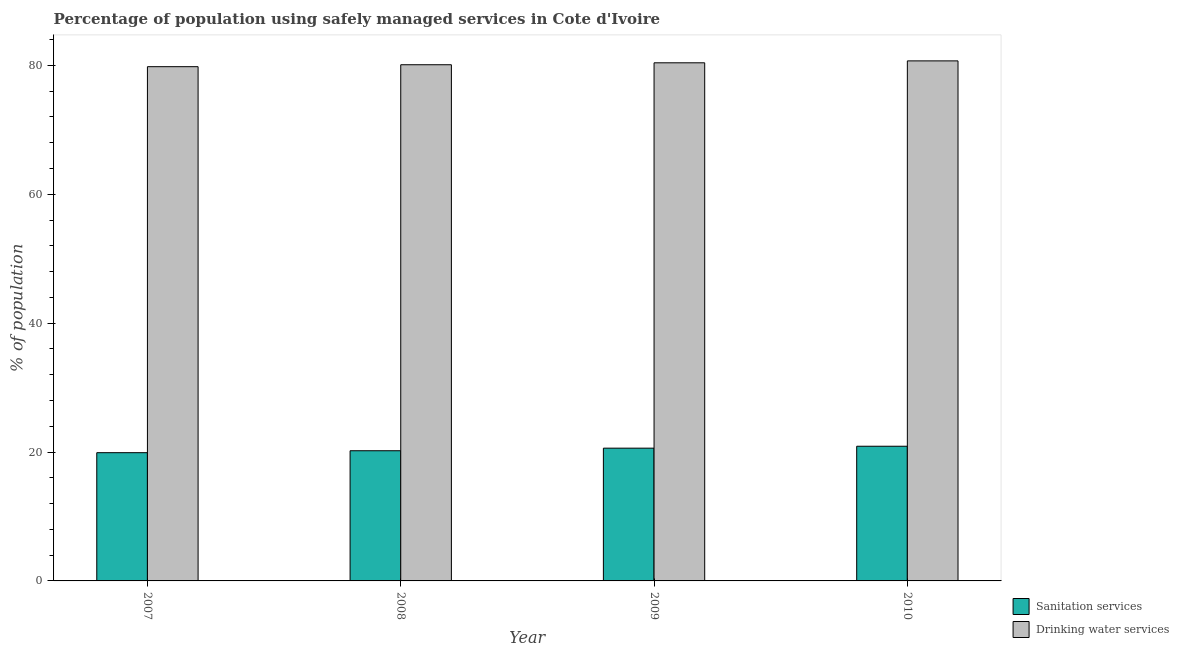How many groups of bars are there?
Offer a terse response. 4. Are the number of bars on each tick of the X-axis equal?
Provide a short and direct response. Yes. How many bars are there on the 3rd tick from the right?
Provide a succinct answer. 2. What is the label of the 4th group of bars from the left?
Keep it short and to the point. 2010. What is the percentage of population who used drinking water services in 2008?
Provide a short and direct response. 80.1. Across all years, what is the maximum percentage of population who used sanitation services?
Offer a terse response. 20.9. In which year was the percentage of population who used sanitation services maximum?
Offer a terse response. 2010. In which year was the percentage of population who used drinking water services minimum?
Provide a short and direct response. 2007. What is the total percentage of population who used drinking water services in the graph?
Make the answer very short. 321. What is the difference between the percentage of population who used drinking water services in 2007 and that in 2009?
Give a very brief answer. -0.6. What is the difference between the percentage of population who used drinking water services in 2008 and the percentage of population who used sanitation services in 2009?
Your response must be concise. -0.3. What is the average percentage of population who used sanitation services per year?
Offer a very short reply. 20.4. In how many years, is the percentage of population who used sanitation services greater than 68 %?
Ensure brevity in your answer.  0. What is the ratio of the percentage of population who used sanitation services in 2008 to that in 2009?
Make the answer very short. 0.98. Is the percentage of population who used drinking water services in 2007 less than that in 2010?
Offer a terse response. Yes. What is the difference between the highest and the second highest percentage of population who used drinking water services?
Your response must be concise. 0.3. What is the difference between the highest and the lowest percentage of population who used drinking water services?
Offer a terse response. 0.9. What does the 2nd bar from the left in 2010 represents?
Keep it short and to the point. Drinking water services. What does the 1st bar from the right in 2008 represents?
Your answer should be compact. Drinking water services. How many bars are there?
Provide a short and direct response. 8. How many years are there in the graph?
Keep it short and to the point. 4. Does the graph contain grids?
Keep it short and to the point. No. How many legend labels are there?
Your response must be concise. 2. How are the legend labels stacked?
Your answer should be very brief. Vertical. What is the title of the graph?
Give a very brief answer. Percentage of population using safely managed services in Cote d'Ivoire. What is the label or title of the Y-axis?
Keep it short and to the point. % of population. What is the % of population of Drinking water services in 2007?
Your response must be concise. 79.8. What is the % of population in Sanitation services in 2008?
Your answer should be very brief. 20.2. What is the % of population of Drinking water services in 2008?
Ensure brevity in your answer.  80.1. What is the % of population in Sanitation services in 2009?
Your answer should be very brief. 20.6. What is the % of population in Drinking water services in 2009?
Offer a terse response. 80.4. What is the % of population of Sanitation services in 2010?
Offer a terse response. 20.9. What is the % of population in Drinking water services in 2010?
Provide a succinct answer. 80.7. Across all years, what is the maximum % of population in Sanitation services?
Offer a terse response. 20.9. Across all years, what is the maximum % of population of Drinking water services?
Provide a short and direct response. 80.7. Across all years, what is the minimum % of population of Sanitation services?
Your response must be concise. 19.9. Across all years, what is the minimum % of population of Drinking water services?
Offer a terse response. 79.8. What is the total % of population in Sanitation services in the graph?
Ensure brevity in your answer.  81.6. What is the total % of population in Drinking water services in the graph?
Ensure brevity in your answer.  321. What is the difference between the % of population in Sanitation services in 2007 and that in 2008?
Keep it short and to the point. -0.3. What is the difference between the % of population in Sanitation services in 2007 and that in 2010?
Your response must be concise. -1. What is the difference between the % of population in Drinking water services in 2007 and that in 2010?
Ensure brevity in your answer.  -0.9. What is the difference between the % of population of Drinking water services in 2008 and that in 2009?
Your response must be concise. -0.3. What is the difference between the % of population in Sanitation services in 2008 and that in 2010?
Provide a succinct answer. -0.7. What is the difference between the % of population of Drinking water services in 2009 and that in 2010?
Offer a very short reply. -0.3. What is the difference between the % of population in Sanitation services in 2007 and the % of population in Drinking water services in 2008?
Your answer should be very brief. -60.2. What is the difference between the % of population of Sanitation services in 2007 and the % of population of Drinking water services in 2009?
Offer a very short reply. -60.5. What is the difference between the % of population in Sanitation services in 2007 and the % of population in Drinking water services in 2010?
Your answer should be compact. -60.8. What is the difference between the % of population of Sanitation services in 2008 and the % of population of Drinking water services in 2009?
Provide a succinct answer. -60.2. What is the difference between the % of population of Sanitation services in 2008 and the % of population of Drinking water services in 2010?
Your answer should be very brief. -60.5. What is the difference between the % of population in Sanitation services in 2009 and the % of population in Drinking water services in 2010?
Provide a short and direct response. -60.1. What is the average % of population of Sanitation services per year?
Your answer should be very brief. 20.4. What is the average % of population of Drinking water services per year?
Offer a terse response. 80.25. In the year 2007, what is the difference between the % of population of Sanitation services and % of population of Drinking water services?
Make the answer very short. -59.9. In the year 2008, what is the difference between the % of population of Sanitation services and % of population of Drinking water services?
Provide a succinct answer. -59.9. In the year 2009, what is the difference between the % of population of Sanitation services and % of population of Drinking water services?
Offer a terse response. -59.8. In the year 2010, what is the difference between the % of population in Sanitation services and % of population in Drinking water services?
Keep it short and to the point. -59.8. What is the ratio of the % of population of Sanitation services in 2007 to that in 2008?
Your answer should be compact. 0.99. What is the ratio of the % of population in Drinking water services in 2007 to that in 2008?
Provide a short and direct response. 1. What is the ratio of the % of population of Sanitation services in 2007 to that in 2010?
Provide a succinct answer. 0.95. What is the ratio of the % of population in Sanitation services in 2008 to that in 2009?
Offer a very short reply. 0.98. What is the ratio of the % of population of Drinking water services in 2008 to that in 2009?
Provide a short and direct response. 1. What is the ratio of the % of population in Sanitation services in 2008 to that in 2010?
Make the answer very short. 0.97. What is the ratio of the % of population in Sanitation services in 2009 to that in 2010?
Make the answer very short. 0.99. What is the ratio of the % of population in Drinking water services in 2009 to that in 2010?
Offer a terse response. 1. What is the difference between the highest and the second highest % of population in Drinking water services?
Your answer should be compact. 0.3. What is the difference between the highest and the lowest % of population in Sanitation services?
Make the answer very short. 1. What is the difference between the highest and the lowest % of population of Drinking water services?
Offer a very short reply. 0.9. 